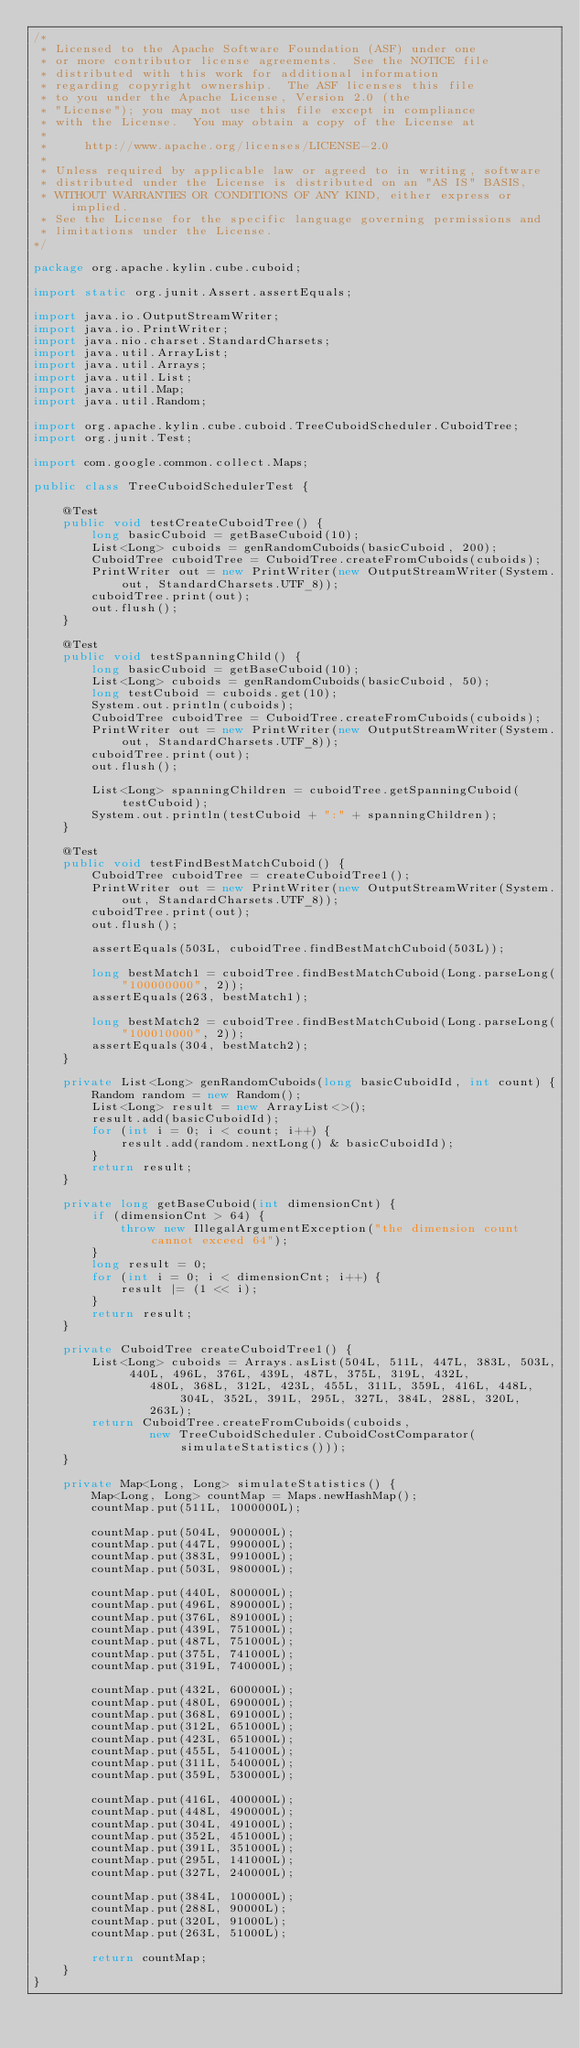<code> <loc_0><loc_0><loc_500><loc_500><_Java_>/*
 * Licensed to the Apache Software Foundation (ASF) under one
 * or more contributor license agreements.  See the NOTICE file
 * distributed with this work for additional information
 * regarding copyright ownership.  The ASF licenses this file
 * to you under the Apache License, Version 2.0 (the
 * "License"); you may not use this file except in compliance
 * with the License.  You may obtain a copy of the License at
 *
 *     http://www.apache.org/licenses/LICENSE-2.0
 *
 * Unless required by applicable law or agreed to in writing, software
 * distributed under the License is distributed on an "AS IS" BASIS,
 * WITHOUT WARRANTIES OR CONDITIONS OF ANY KIND, either express or implied.
 * See the License for the specific language governing permissions and
 * limitations under the License.
*/

package org.apache.kylin.cube.cuboid;

import static org.junit.Assert.assertEquals;

import java.io.OutputStreamWriter;
import java.io.PrintWriter;
import java.nio.charset.StandardCharsets;
import java.util.ArrayList;
import java.util.Arrays;
import java.util.List;
import java.util.Map;
import java.util.Random;

import org.apache.kylin.cube.cuboid.TreeCuboidScheduler.CuboidTree;
import org.junit.Test;

import com.google.common.collect.Maps;

public class TreeCuboidSchedulerTest {

    @Test
    public void testCreateCuboidTree() {
        long basicCuboid = getBaseCuboid(10);
        List<Long> cuboids = genRandomCuboids(basicCuboid, 200);
        CuboidTree cuboidTree = CuboidTree.createFromCuboids(cuboids);
        PrintWriter out = new PrintWriter(new OutputStreamWriter(System.out, StandardCharsets.UTF_8));
        cuboidTree.print(out);
        out.flush();
    }

    @Test
    public void testSpanningChild() {
        long basicCuboid = getBaseCuboid(10);
        List<Long> cuboids = genRandomCuboids(basicCuboid, 50);
        long testCuboid = cuboids.get(10);
        System.out.println(cuboids);
        CuboidTree cuboidTree = CuboidTree.createFromCuboids(cuboids);
        PrintWriter out = new PrintWriter(new OutputStreamWriter(System.out, StandardCharsets.UTF_8));
        cuboidTree.print(out);
        out.flush();

        List<Long> spanningChildren = cuboidTree.getSpanningCuboid(testCuboid);
        System.out.println(testCuboid + ":" + spanningChildren);
    }

    @Test
    public void testFindBestMatchCuboid() {
        CuboidTree cuboidTree = createCuboidTree1();
        PrintWriter out = new PrintWriter(new OutputStreamWriter(System.out, StandardCharsets.UTF_8));
        cuboidTree.print(out);
        out.flush();

        assertEquals(503L, cuboidTree.findBestMatchCuboid(503L));

        long bestMatch1 = cuboidTree.findBestMatchCuboid(Long.parseLong("100000000", 2));
        assertEquals(263, bestMatch1);

        long bestMatch2 = cuboidTree.findBestMatchCuboid(Long.parseLong("100010000", 2));
        assertEquals(304, bestMatch2);
    }

    private List<Long> genRandomCuboids(long basicCuboidId, int count) {
        Random random = new Random();
        List<Long> result = new ArrayList<>();
        result.add(basicCuboidId);
        for (int i = 0; i < count; i++) {
            result.add(random.nextLong() & basicCuboidId);
        }
        return result;
    }

    private long getBaseCuboid(int dimensionCnt) {
        if (dimensionCnt > 64) {
            throw new IllegalArgumentException("the dimension count cannot exceed 64");
        }
        long result = 0;
        for (int i = 0; i < dimensionCnt; i++) {
            result |= (1 << i);
        }
        return result;
    }

    private CuboidTree createCuboidTree1() {
        List<Long> cuboids = Arrays.asList(504L, 511L, 447L, 383L, 503L, 440L, 496L, 376L, 439L, 487L, 375L, 319L, 432L,
                480L, 368L, 312L, 423L, 455L, 311L, 359L, 416L, 448L, 304L, 352L, 391L, 295L, 327L, 384L, 288L, 320L,
                263L);
        return CuboidTree.createFromCuboids(cuboids,
                new TreeCuboidScheduler.CuboidCostComparator(simulateStatistics()));
    }

    private Map<Long, Long> simulateStatistics() {
        Map<Long, Long> countMap = Maps.newHashMap();
        countMap.put(511L, 1000000L);

        countMap.put(504L, 900000L);
        countMap.put(447L, 990000L);
        countMap.put(383L, 991000L);
        countMap.put(503L, 980000L);

        countMap.put(440L, 800000L);
        countMap.put(496L, 890000L);
        countMap.put(376L, 891000L);
        countMap.put(439L, 751000L);
        countMap.put(487L, 751000L);
        countMap.put(375L, 741000L);
        countMap.put(319L, 740000L);

        countMap.put(432L, 600000L);
        countMap.put(480L, 690000L);
        countMap.put(368L, 691000L);
        countMap.put(312L, 651000L);
        countMap.put(423L, 651000L);
        countMap.put(455L, 541000L);
        countMap.put(311L, 540000L);
        countMap.put(359L, 530000L);

        countMap.put(416L, 400000L);
        countMap.put(448L, 490000L);
        countMap.put(304L, 491000L);
        countMap.put(352L, 451000L);
        countMap.put(391L, 351000L);
        countMap.put(295L, 141000L);
        countMap.put(327L, 240000L);

        countMap.put(384L, 100000L);
        countMap.put(288L, 90000L);
        countMap.put(320L, 91000L);
        countMap.put(263L, 51000L);

        return countMap;
    }
}
</code> 